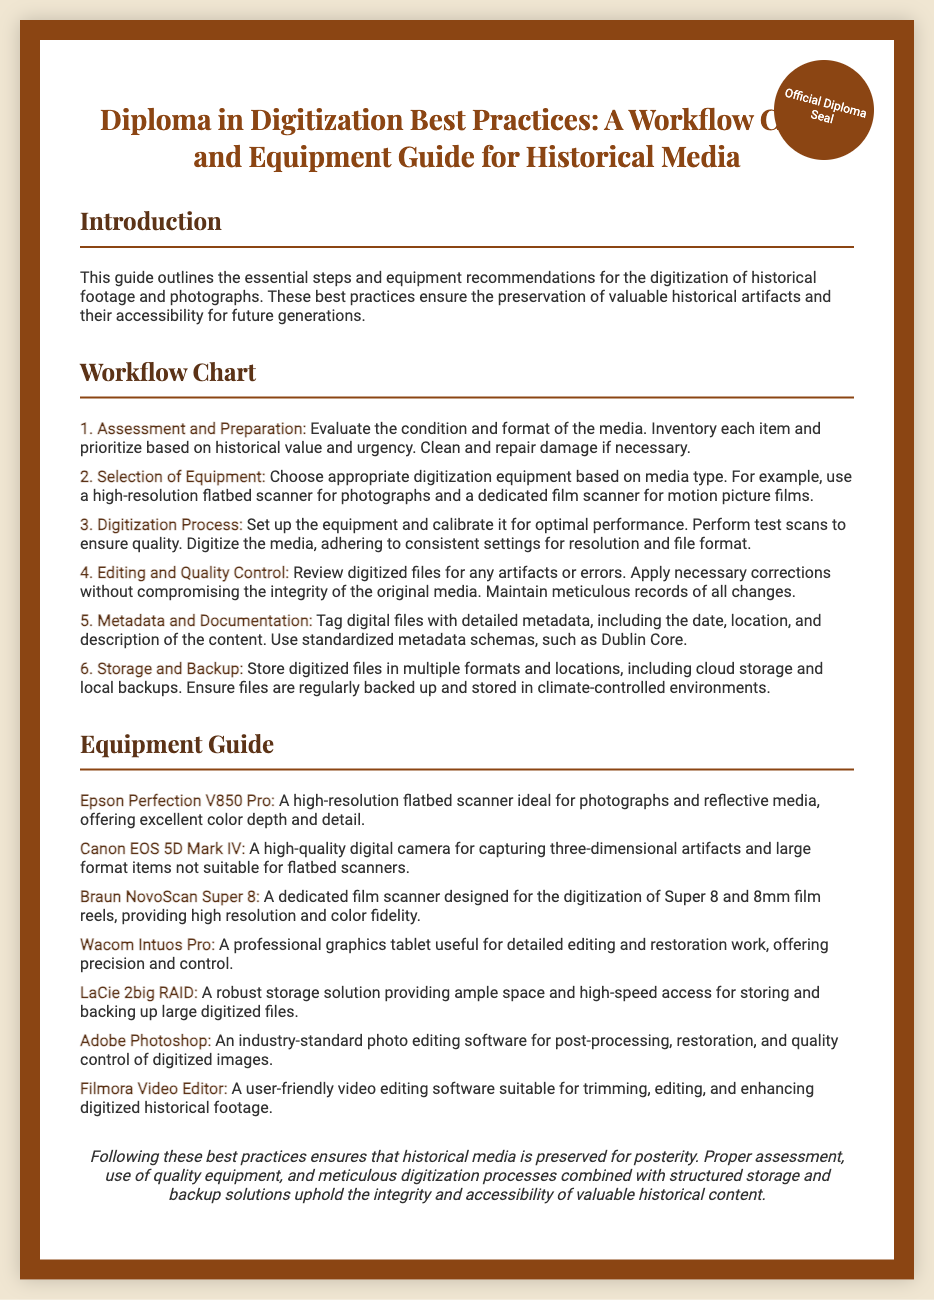What is the title of the diploma? The title of the diploma is stated prominently at the top of the document.
Answer: Diploma in Digitization Best Practices: A Workflow Chart and Equipment Guide for Historical Media How many steps are in the workflow chart? The document lists the steps in the workflow chart, numbered 1 through 6.
Answer: 6 What equipment is recommended for digitizing photographs? The document specifies the equipment suitable for digitizing photographs under the equipment guide section.
Answer: Epson Perfection V850 Pro Which software is mentioned for photo editing? The document includes a specific mention of software used for photo editing in the equipment guide section.
Answer: Adobe Photoshop What should be used for digitizing Super 8 films? The recommendation for digitizing Super 8 films is found under the equipment guide section of the document.
Answer: Braun NovoScan Super 8 What is the recommended storage solution? The document identifies a storage solution that is robust for backing up large digitized files.
Answer: LaCie 2big RAID What metadata schema is suggested for tagging digital files? The document recommends using a specific standardized metadata schema for tagging files.
Answer: Dublin Core What is the primary goal of the document? The introduction of the document states its primary aim regarding historical media preservation.
Answer: Preservation of valuable historical artifacts 